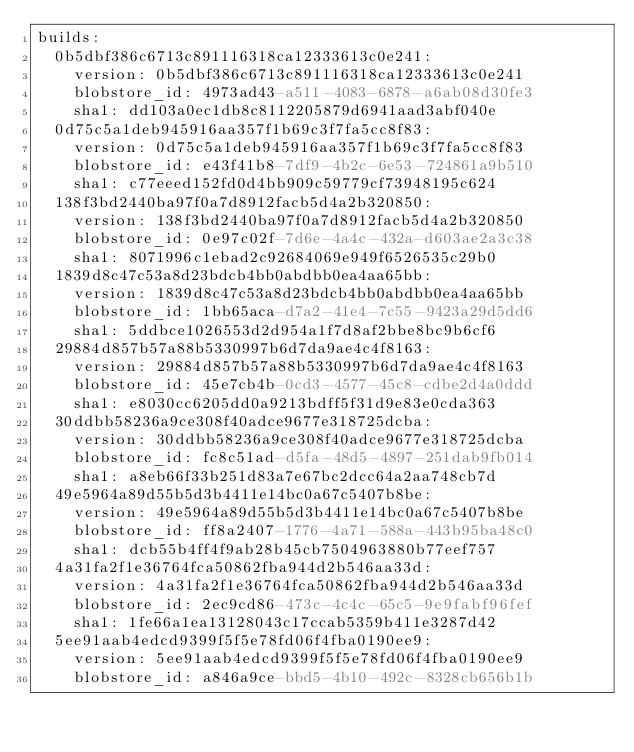Convert code to text. <code><loc_0><loc_0><loc_500><loc_500><_YAML_>builds:
  0b5dbf386c6713c891116318ca12333613c0e241:
    version: 0b5dbf386c6713c891116318ca12333613c0e241
    blobstore_id: 4973ad43-a511-4083-6878-a6ab08d30fe3
    sha1: dd103a0ec1db8c8112205879d6941aad3abf040e
  0d75c5a1deb945916aa357f1b69c3f7fa5cc8f83:
    version: 0d75c5a1deb945916aa357f1b69c3f7fa5cc8f83
    blobstore_id: e43f41b8-7df9-4b2c-6e53-724861a9b510
    sha1: c77eeed152fd0d4bb909c59779cf73948195c624
  138f3bd2440ba97f0a7d8912facb5d4a2b320850:
    version: 138f3bd2440ba97f0a7d8912facb5d4a2b320850
    blobstore_id: 0e97c02f-7d6e-4a4c-432a-d603ae2a3c38
    sha1: 8071996c1ebad2c92684069e949f6526535c29b0
  1839d8c47c53a8d23bdcb4bb0abdbb0ea4aa65bb:
    version: 1839d8c47c53a8d23bdcb4bb0abdbb0ea4aa65bb
    blobstore_id: 1bb65aca-d7a2-41e4-7c55-9423a29d5dd6
    sha1: 5ddbce1026553d2d954a1f7d8af2bbe8bc9b6cf6
  29884d857b57a88b5330997b6d7da9ae4c4f8163:
    version: 29884d857b57a88b5330997b6d7da9ae4c4f8163
    blobstore_id: 45e7cb4b-0cd3-4577-45c8-cdbe2d4a0ddd
    sha1: e8030cc6205dd0a9213bdff5f31d9e83e0cda363
  30ddbb58236a9ce308f40adce9677e318725dcba:
    version: 30ddbb58236a9ce308f40adce9677e318725dcba
    blobstore_id: fc8c51ad-d5fa-48d5-4897-251dab9fb014
    sha1: a8eb66f33b251d83a7e67bc2dcc64a2aa748cb7d
  49e5964a89d55b5d3b4411e14bc0a67c5407b8be:
    version: 49e5964a89d55b5d3b4411e14bc0a67c5407b8be
    blobstore_id: ff8a2407-1776-4a71-588a-443b95ba48c0
    sha1: dcb55b4ff4f9ab28b45cb7504963880b77eef757
  4a31fa2f1e36764fca50862fba944d2b546aa33d:
    version: 4a31fa2f1e36764fca50862fba944d2b546aa33d
    blobstore_id: 2ec9cd86-473c-4c4c-65c5-9e9fabf96fef
    sha1: 1fe66a1ea13128043c17ccab5359b411e3287d42
  5ee91aab4edcd9399f5f5e78fd06f4fba0190ee9:
    version: 5ee91aab4edcd9399f5f5e78fd06f4fba0190ee9
    blobstore_id: a846a9ce-bbd5-4b10-492c-8328cb656b1b</code> 